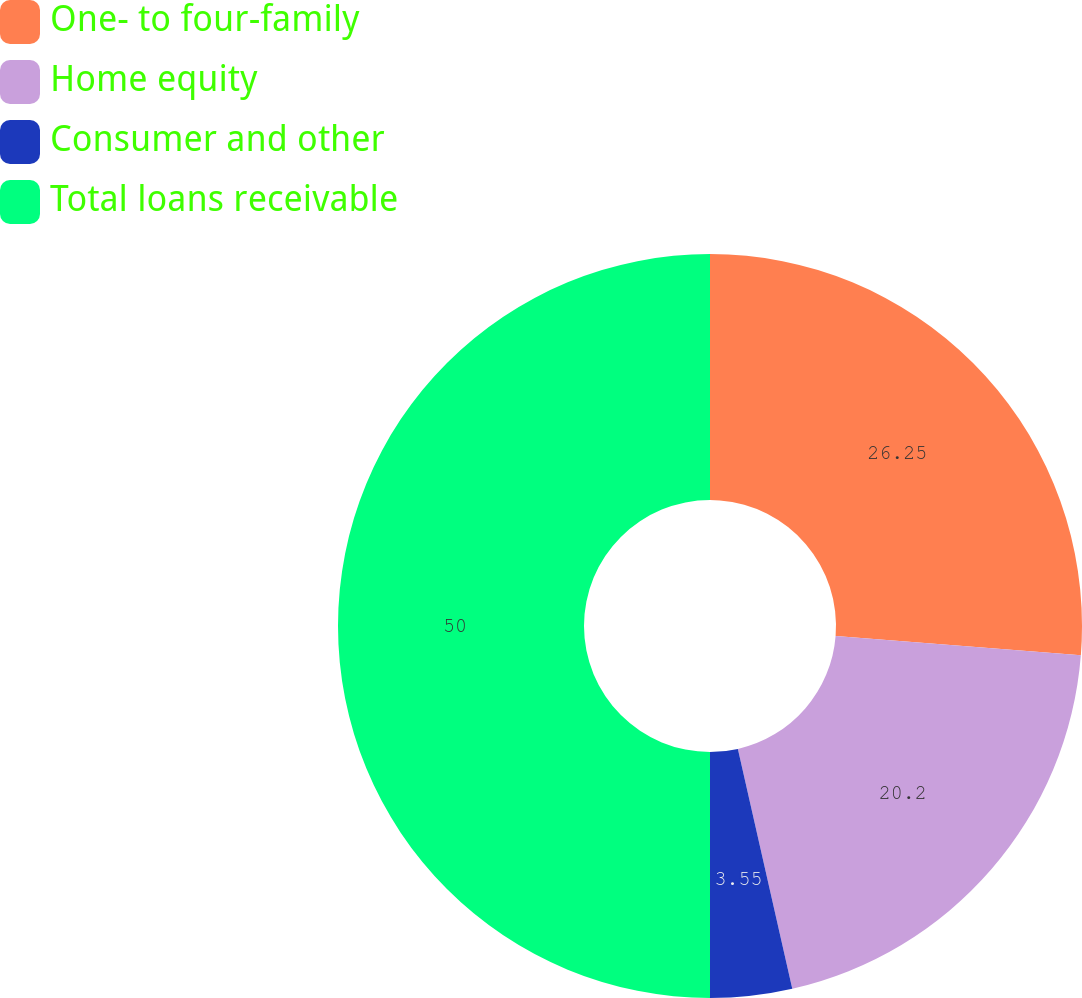<chart> <loc_0><loc_0><loc_500><loc_500><pie_chart><fcel>One- to four-family<fcel>Home equity<fcel>Consumer and other<fcel>Total loans receivable<nl><fcel>26.25%<fcel>20.2%<fcel>3.55%<fcel>50.0%<nl></chart> 